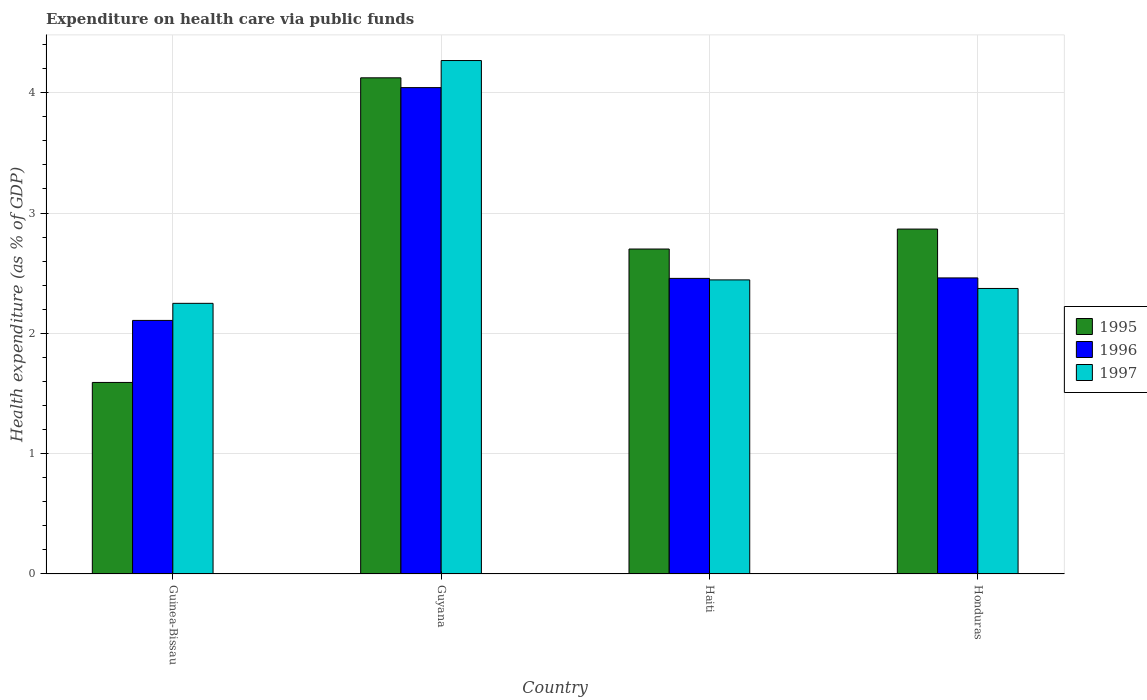How many different coloured bars are there?
Offer a very short reply. 3. Are the number of bars on each tick of the X-axis equal?
Offer a terse response. Yes. How many bars are there on the 3rd tick from the right?
Provide a short and direct response. 3. What is the label of the 2nd group of bars from the left?
Offer a terse response. Guyana. What is the expenditure made on health care in 1996 in Honduras?
Offer a terse response. 2.46. Across all countries, what is the maximum expenditure made on health care in 1996?
Your response must be concise. 4.04. Across all countries, what is the minimum expenditure made on health care in 1995?
Keep it short and to the point. 1.59. In which country was the expenditure made on health care in 1996 maximum?
Provide a succinct answer. Guyana. In which country was the expenditure made on health care in 1995 minimum?
Provide a succinct answer. Guinea-Bissau. What is the total expenditure made on health care in 1996 in the graph?
Offer a terse response. 11.07. What is the difference between the expenditure made on health care in 1996 in Guinea-Bissau and that in Haiti?
Give a very brief answer. -0.35. What is the difference between the expenditure made on health care in 1995 in Haiti and the expenditure made on health care in 1997 in Guinea-Bissau?
Keep it short and to the point. 0.45. What is the average expenditure made on health care in 1997 per country?
Give a very brief answer. 2.83. What is the difference between the expenditure made on health care of/in 1997 and expenditure made on health care of/in 1996 in Haiti?
Make the answer very short. -0.01. In how many countries, is the expenditure made on health care in 1997 greater than 1.2 %?
Your response must be concise. 4. What is the ratio of the expenditure made on health care in 1996 in Guinea-Bissau to that in Honduras?
Provide a short and direct response. 0.86. Is the expenditure made on health care in 1996 in Guyana less than that in Honduras?
Offer a terse response. No. Is the difference between the expenditure made on health care in 1997 in Guyana and Honduras greater than the difference between the expenditure made on health care in 1996 in Guyana and Honduras?
Keep it short and to the point. Yes. What is the difference between the highest and the second highest expenditure made on health care in 1997?
Offer a terse response. 0.07. What is the difference between the highest and the lowest expenditure made on health care in 1997?
Provide a short and direct response. 2.02. In how many countries, is the expenditure made on health care in 1997 greater than the average expenditure made on health care in 1997 taken over all countries?
Your answer should be very brief. 1. Is the sum of the expenditure made on health care in 1996 in Guyana and Honduras greater than the maximum expenditure made on health care in 1997 across all countries?
Give a very brief answer. Yes. Are all the bars in the graph horizontal?
Your answer should be compact. No. How many countries are there in the graph?
Your answer should be very brief. 4. Are the values on the major ticks of Y-axis written in scientific E-notation?
Your answer should be very brief. No. Does the graph contain grids?
Your answer should be very brief. Yes. Where does the legend appear in the graph?
Give a very brief answer. Center right. How are the legend labels stacked?
Offer a very short reply. Vertical. What is the title of the graph?
Make the answer very short. Expenditure on health care via public funds. Does "1969" appear as one of the legend labels in the graph?
Make the answer very short. No. What is the label or title of the X-axis?
Make the answer very short. Country. What is the label or title of the Y-axis?
Give a very brief answer. Health expenditure (as % of GDP). What is the Health expenditure (as % of GDP) of 1995 in Guinea-Bissau?
Provide a short and direct response. 1.59. What is the Health expenditure (as % of GDP) of 1996 in Guinea-Bissau?
Make the answer very short. 2.11. What is the Health expenditure (as % of GDP) of 1997 in Guinea-Bissau?
Offer a very short reply. 2.25. What is the Health expenditure (as % of GDP) of 1995 in Guyana?
Provide a short and direct response. 4.12. What is the Health expenditure (as % of GDP) of 1996 in Guyana?
Provide a succinct answer. 4.04. What is the Health expenditure (as % of GDP) in 1997 in Guyana?
Your answer should be compact. 4.27. What is the Health expenditure (as % of GDP) of 1995 in Haiti?
Your answer should be compact. 2.7. What is the Health expenditure (as % of GDP) of 1996 in Haiti?
Provide a succinct answer. 2.46. What is the Health expenditure (as % of GDP) of 1997 in Haiti?
Your answer should be very brief. 2.44. What is the Health expenditure (as % of GDP) in 1995 in Honduras?
Make the answer very short. 2.87. What is the Health expenditure (as % of GDP) in 1996 in Honduras?
Offer a terse response. 2.46. What is the Health expenditure (as % of GDP) in 1997 in Honduras?
Offer a terse response. 2.37. Across all countries, what is the maximum Health expenditure (as % of GDP) in 1995?
Your answer should be very brief. 4.12. Across all countries, what is the maximum Health expenditure (as % of GDP) in 1996?
Provide a short and direct response. 4.04. Across all countries, what is the maximum Health expenditure (as % of GDP) of 1997?
Provide a succinct answer. 4.27. Across all countries, what is the minimum Health expenditure (as % of GDP) in 1995?
Provide a succinct answer. 1.59. Across all countries, what is the minimum Health expenditure (as % of GDP) in 1996?
Provide a succinct answer. 2.11. Across all countries, what is the minimum Health expenditure (as % of GDP) of 1997?
Make the answer very short. 2.25. What is the total Health expenditure (as % of GDP) in 1995 in the graph?
Offer a very short reply. 11.28. What is the total Health expenditure (as % of GDP) of 1996 in the graph?
Keep it short and to the point. 11.07. What is the total Health expenditure (as % of GDP) of 1997 in the graph?
Offer a terse response. 11.33. What is the difference between the Health expenditure (as % of GDP) of 1995 in Guinea-Bissau and that in Guyana?
Your answer should be very brief. -2.53. What is the difference between the Health expenditure (as % of GDP) of 1996 in Guinea-Bissau and that in Guyana?
Offer a very short reply. -1.93. What is the difference between the Health expenditure (as % of GDP) of 1997 in Guinea-Bissau and that in Guyana?
Give a very brief answer. -2.02. What is the difference between the Health expenditure (as % of GDP) in 1995 in Guinea-Bissau and that in Haiti?
Provide a succinct answer. -1.11. What is the difference between the Health expenditure (as % of GDP) of 1996 in Guinea-Bissau and that in Haiti?
Make the answer very short. -0.35. What is the difference between the Health expenditure (as % of GDP) of 1997 in Guinea-Bissau and that in Haiti?
Your answer should be very brief. -0.19. What is the difference between the Health expenditure (as % of GDP) in 1995 in Guinea-Bissau and that in Honduras?
Your answer should be very brief. -1.27. What is the difference between the Health expenditure (as % of GDP) of 1996 in Guinea-Bissau and that in Honduras?
Offer a terse response. -0.35. What is the difference between the Health expenditure (as % of GDP) in 1997 in Guinea-Bissau and that in Honduras?
Make the answer very short. -0.12. What is the difference between the Health expenditure (as % of GDP) in 1995 in Guyana and that in Haiti?
Offer a terse response. 1.42. What is the difference between the Health expenditure (as % of GDP) of 1996 in Guyana and that in Haiti?
Offer a very short reply. 1.59. What is the difference between the Health expenditure (as % of GDP) of 1997 in Guyana and that in Haiti?
Make the answer very short. 1.82. What is the difference between the Health expenditure (as % of GDP) in 1995 in Guyana and that in Honduras?
Your response must be concise. 1.26. What is the difference between the Health expenditure (as % of GDP) in 1996 in Guyana and that in Honduras?
Ensure brevity in your answer.  1.58. What is the difference between the Health expenditure (as % of GDP) in 1997 in Guyana and that in Honduras?
Provide a short and direct response. 1.89. What is the difference between the Health expenditure (as % of GDP) of 1995 in Haiti and that in Honduras?
Your answer should be very brief. -0.17. What is the difference between the Health expenditure (as % of GDP) in 1996 in Haiti and that in Honduras?
Make the answer very short. -0. What is the difference between the Health expenditure (as % of GDP) in 1997 in Haiti and that in Honduras?
Make the answer very short. 0.07. What is the difference between the Health expenditure (as % of GDP) in 1995 in Guinea-Bissau and the Health expenditure (as % of GDP) in 1996 in Guyana?
Offer a very short reply. -2.45. What is the difference between the Health expenditure (as % of GDP) of 1995 in Guinea-Bissau and the Health expenditure (as % of GDP) of 1997 in Guyana?
Offer a terse response. -2.68. What is the difference between the Health expenditure (as % of GDP) in 1996 in Guinea-Bissau and the Health expenditure (as % of GDP) in 1997 in Guyana?
Your answer should be very brief. -2.16. What is the difference between the Health expenditure (as % of GDP) of 1995 in Guinea-Bissau and the Health expenditure (as % of GDP) of 1996 in Haiti?
Offer a very short reply. -0.86. What is the difference between the Health expenditure (as % of GDP) in 1995 in Guinea-Bissau and the Health expenditure (as % of GDP) in 1997 in Haiti?
Give a very brief answer. -0.85. What is the difference between the Health expenditure (as % of GDP) in 1996 in Guinea-Bissau and the Health expenditure (as % of GDP) in 1997 in Haiti?
Your answer should be very brief. -0.34. What is the difference between the Health expenditure (as % of GDP) in 1995 in Guinea-Bissau and the Health expenditure (as % of GDP) in 1996 in Honduras?
Give a very brief answer. -0.87. What is the difference between the Health expenditure (as % of GDP) in 1995 in Guinea-Bissau and the Health expenditure (as % of GDP) in 1997 in Honduras?
Your answer should be very brief. -0.78. What is the difference between the Health expenditure (as % of GDP) of 1996 in Guinea-Bissau and the Health expenditure (as % of GDP) of 1997 in Honduras?
Offer a terse response. -0.27. What is the difference between the Health expenditure (as % of GDP) of 1995 in Guyana and the Health expenditure (as % of GDP) of 1996 in Haiti?
Your answer should be very brief. 1.67. What is the difference between the Health expenditure (as % of GDP) in 1995 in Guyana and the Health expenditure (as % of GDP) in 1997 in Haiti?
Provide a succinct answer. 1.68. What is the difference between the Health expenditure (as % of GDP) of 1996 in Guyana and the Health expenditure (as % of GDP) of 1997 in Haiti?
Your answer should be very brief. 1.6. What is the difference between the Health expenditure (as % of GDP) of 1995 in Guyana and the Health expenditure (as % of GDP) of 1996 in Honduras?
Make the answer very short. 1.66. What is the difference between the Health expenditure (as % of GDP) of 1995 in Guyana and the Health expenditure (as % of GDP) of 1997 in Honduras?
Offer a very short reply. 1.75. What is the difference between the Health expenditure (as % of GDP) in 1996 in Guyana and the Health expenditure (as % of GDP) in 1997 in Honduras?
Make the answer very short. 1.67. What is the difference between the Health expenditure (as % of GDP) in 1995 in Haiti and the Health expenditure (as % of GDP) in 1996 in Honduras?
Your answer should be very brief. 0.24. What is the difference between the Health expenditure (as % of GDP) in 1995 in Haiti and the Health expenditure (as % of GDP) in 1997 in Honduras?
Provide a short and direct response. 0.33. What is the difference between the Health expenditure (as % of GDP) of 1996 in Haiti and the Health expenditure (as % of GDP) of 1997 in Honduras?
Give a very brief answer. 0.08. What is the average Health expenditure (as % of GDP) of 1995 per country?
Your answer should be compact. 2.82. What is the average Health expenditure (as % of GDP) of 1996 per country?
Give a very brief answer. 2.77. What is the average Health expenditure (as % of GDP) of 1997 per country?
Provide a short and direct response. 2.83. What is the difference between the Health expenditure (as % of GDP) in 1995 and Health expenditure (as % of GDP) in 1996 in Guinea-Bissau?
Offer a very short reply. -0.52. What is the difference between the Health expenditure (as % of GDP) of 1995 and Health expenditure (as % of GDP) of 1997 in Guinea-Bissau?
Provide a short and direct response. -0.66. What is the difference between the Health expenditure (as % of GDP) in 1996 and Health expenditure (as % of GDP) in 1997 in Guinea-Bissau?
Offer a very short reply. -0.14. What is the difference between the Health expenditure (as % of GDP) in 1995 and Health expenditure (as % of GDP) in 1996 in Guyana?
Provide a short and direct response. 0.08. What is the difference between the Health expenditure (as % of GDP) in 1995 and Health expenditure (as % of GDP) in 1997 in Guyana?
Offer a very short reply. -0.14. What is the difference between the Health expenditure (as % of GDP) in 1996 and Health expenditure (as % of GDP) in 1997 in Guyana?
Give a very brief answer. -0.23. What is the difference between the Health expenditure (as % of GDP) in 1995 and Health expenditure (as % of GDP) in 1996 in Haiti?
Provide a succinct answer. 0.24. What is the difference between the Health expenditure (as % of GDP) of 1995 and Health expenditure (as % of GDP) of 1997 in Haiti?
Make the answer very short. 0.26. What is the difference between the Health expenditure (as % of GDP) of 1996 and Health expenditure (as % of GDP) of 1997 in Haiti?
Offer a terse response. 0.01. What is the difference between the Health expenditure (as % of GDP) in 1995 and Health expenditure (as % of GDP) in 1996 in Honduras?
Offer a terse response. 0.41. What is the difference between the Health expenditure (as % of GDP) in 1995 and Health expenditure (as % of GDP) in 1997 in Honduras?
Offer a very short reply. 0.49. What is the difference between the Health expenditure (as % of GDP) in 1996 and Health expenditure (as % of GDP) in 1997 in Honduras?
Offer a very short reply. 0.09. What is the ratio of the Health expenditure (as % of GDP) in 1995 in Guinea-Bissau to that in Guyana?
Offer a very short reply. 0.39. What is the ratio of the Health expenditure (as % of GDP) of 1996 in Guinea-Bissau to that in Guyana?
Provide a short and direct response. 0.52. What is the ratio of the Health expenditure (as % of GDP) in 1997 in Guinea-Bissau to that in Guyana?
Your response must be concise. 0.53. What is the ratio of the Health expenditure (as % of GDP) in 1995 in Guinea-Bissau to that in Haiti?
Make the answer very short. 0.59. What is the ratio of the Health expenditure (as % of GDP) in 1996 in Guinea-Bissau to that in Haiti?
Make the answer very short. 0.86. What is the ratio of the Health expenditure (as % of GDP) in 1997 in Guinea-Bissau to that in Haiti?
Make the answer very short. 0.92. What is the ratio of the Health expenditure (as % of GDP) in 1995 in Guinea-Bissau to that in Honduras?
Offer a very short reply. 0.56. What is the ratio of the Health expenditure (as % of GDP) in 1996 in Guinea-Bissau to that in Honduras?
Make the answer very short. 0.86. What is the ratio of the Health expenditure (as % of GDP) of 1997 in Guinea-Bissau to that in Honduras?
Your answer should be very brief. 0.95. What is the ratio of the Health expenditure (as % of GDP) in 1995 in Guyana to that in Haiti?
Ensure brevity in your answer.  1.53. What is the ratio of the Health expenditure (as % of GDP) in 1996 in Guyana to that in Haiti?
Ensure brevity in your answer.  1.65. What is the ratio of the Health expenditure (as % of GDP) in 1997 in Guyana to that in Haiti?
Your answer should be compact. 1.75. What is the ratio of the Health expenditure (as % of GDP) of 1995 in Guyana to that in Honduras?
Your answer should be compact. 1.44. What is the ratio of the Health expenditure (as % of GDP) in 1996 in Guyana to that in Honduras?
Offer a very short reply. 1.64. What is the ratio of the Health expenditure (as % of GDP) in 1997 in Guyana to that in Honduras?
Offer a very short reply. 1.8. What is the ratio of the Health expenditure (as % of GDP) of 1995 in Haiti to that in Honduras?
Your answer should be compact. 0.94. What is the ratio of the Health expenditure (as % of GDP) of 1996 in Haiti to that in Honduras?
Give a very brief answer. 1. What is the ratio of the Health expenditure (as % of GDP) in 1997 in Haiti to that in Honduras?
Give a very brief answer. 1.03. What is the difference between the highest and the second highest Health expenditure (as % of GDP) of 1995?
Make the answer very short. 1.26. What is the difference between the highest and the second highest Health expenditure (as % of GDP) of 1996?
Offer a terse response. 1.58. What is the difference between the highest and the second highest Health expenditure (as % of GDP) of 1997?
Keep it short and to the point. 1.82. What is the difference between the highest and the lowest Health expenditure (as % of GDP) in 1995?
Offer a very short reply. 2.53. What is the difference between the highest and the lowest Health expenditure (as % of GDP) in 1996?
Make the answer very short. 1.93. What is the difference between the highest and the lowest Health expenditure (as % of GDP) in 1997?
Offer a very short reply. 2.02. 